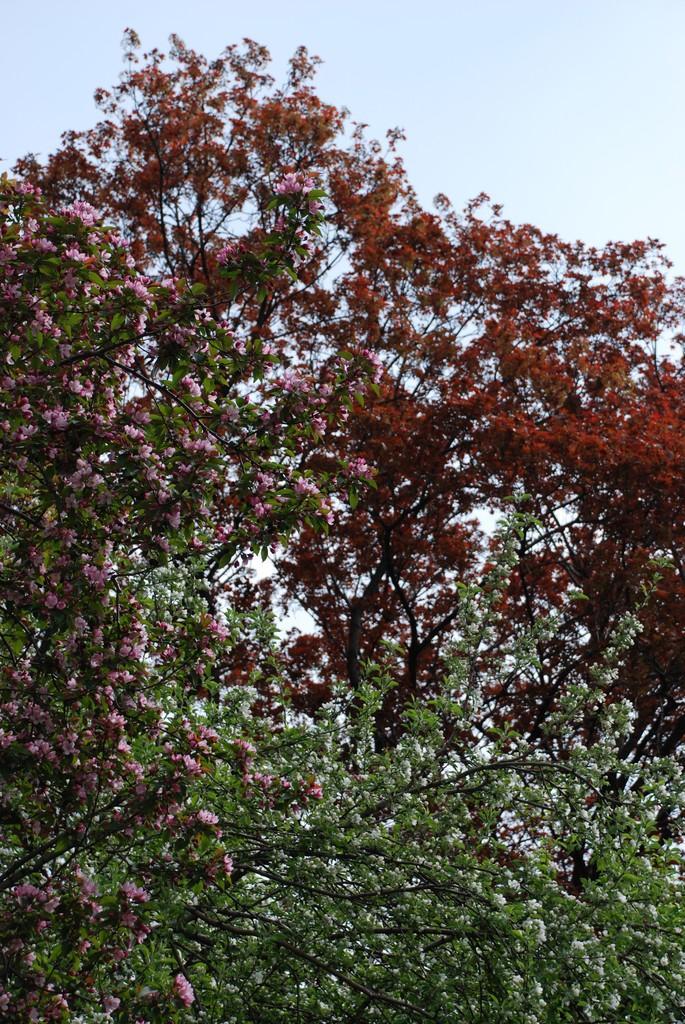Can you describe this image briefly? In the foreground of this image, there are flowers to the trees. At the top, there is the sky. 